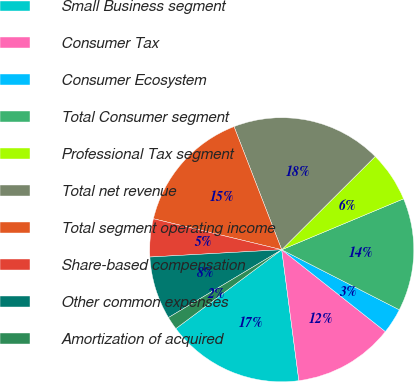Convert chart to OTSL. <chart><loc_0><loc_0><loc_500><loc_500><pie_chart><fcel>Small Business segment<fcel>Consumer Tax<fcel>Consumer Ecosystem<fcel>Total Consumer segment<fcel>Professional Tax segment<fcel>Total net revenue<fcel>Total segment operating income<fcel>Share-based compensation<fcel>Other common expenses<fcel>Amortization of acquired<nl><fcel>16.88%<fcel>12.29%<fcel>3.12%<fcel>13.82%<fcel>6.18%<fcel>18.4%<fcel>15.35%<fcel>4.65%<fcel>7.71%<fcel>1.6%<nl></chart> 